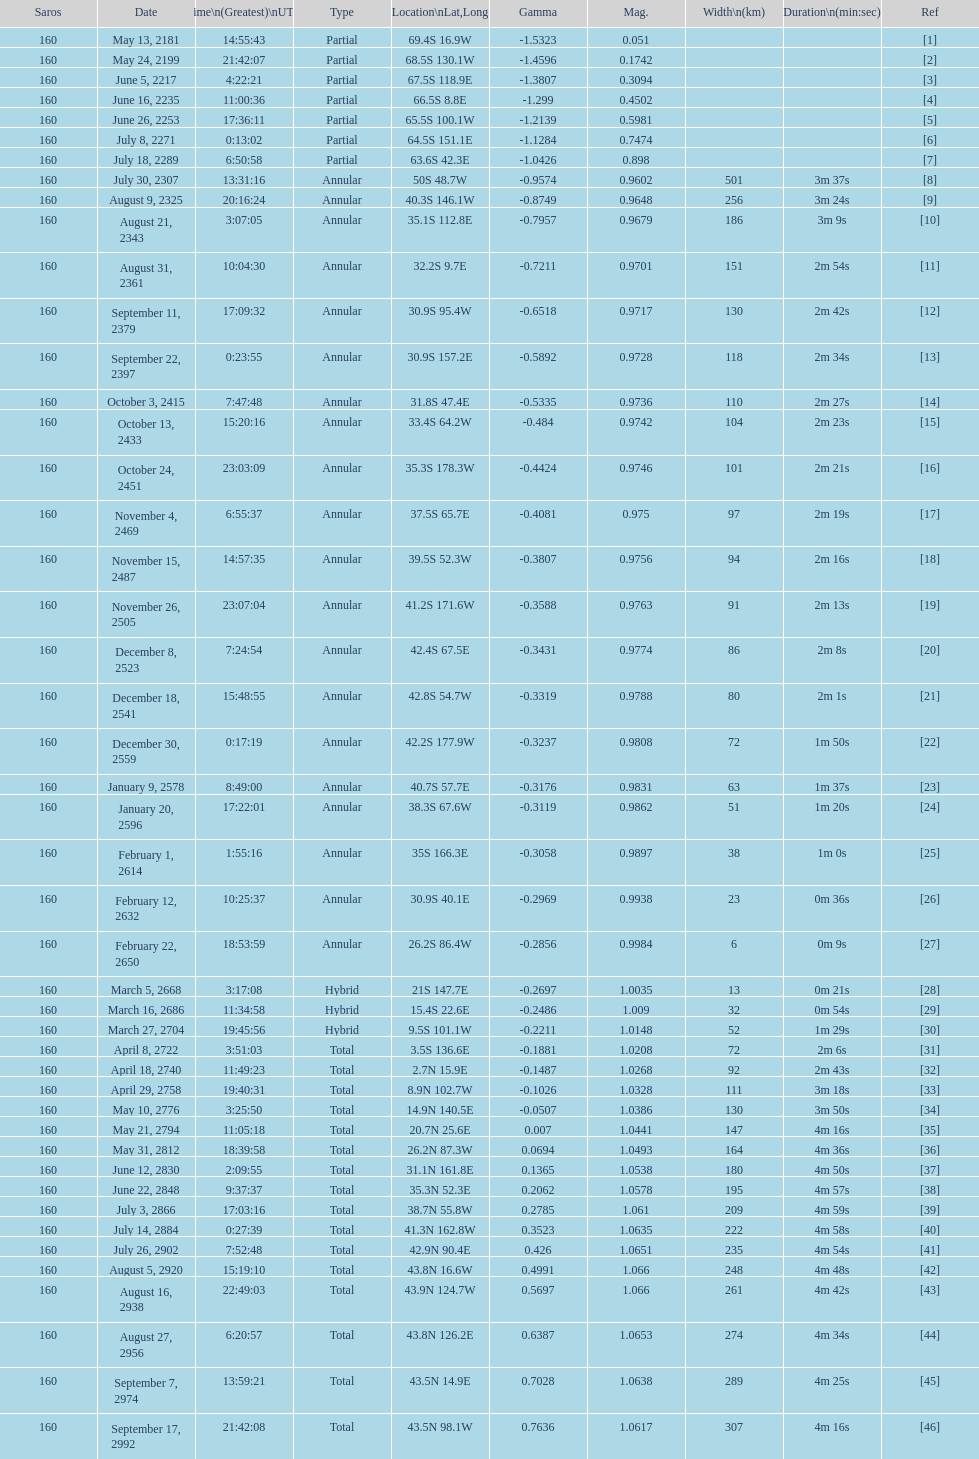How many total events will occur in all? 46. 